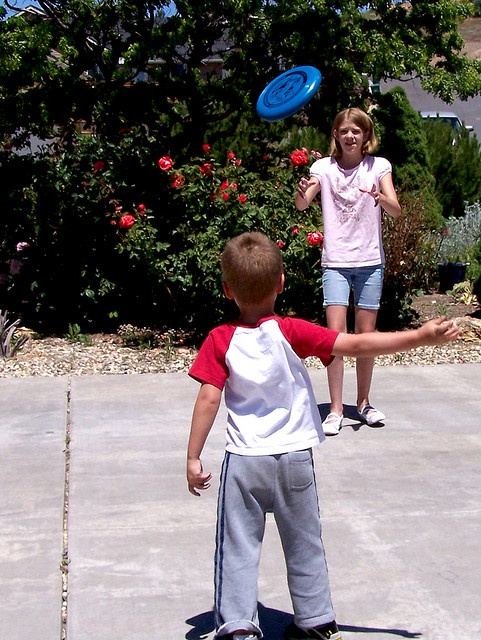Describe the objects in this image and their specific colors. I can see people in lightblue, lavender, darkgray, and gray tones, people in lightblue, lavender, brown, maroon, and black tones, frisbee in lightblue, blue, navy, and black tones, and car in lightblue, black, darkgreen, darkgray, and lightgray tones in this image. 